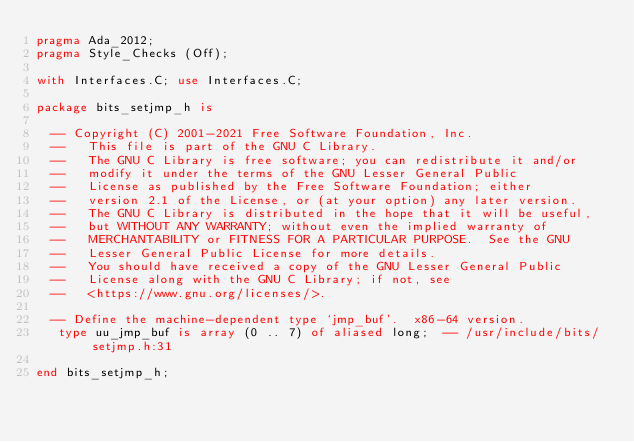<code> <loc_0><loc_0><loc_500><loc_500><_Ada_>pragma Ada_2012;
pragma Style_Checks (Off);

with Interfaces.C; use Interfaces.C;

package bits_setjmp_h is

  -- Copyright (C) 2001-2021 Free Software Foundation, Inc.
  --   This file is part of the GNU C Library.
  --   The GNU C Library is free software; you can redistribute it and/or
  --   modify it under the terms of the GNU Lesser General Public
  --   License as published by the Free Software Foundation; either
  --   version 2.1 of the License, or (at your option) any later version.
  --   The GNU C Library is distributed in the hope that it will be useful,
  --   but WITHOUT ANY WARRANTY; without even the implied warranty of
  --   MERCHANTABILITY or FITNESS FOR A PARTICULAR PURPOSE.  See the GNU
  --   Lesser General Public License for more details.
  --   You should have received a copy of the GNU Lesser General Public
  --   License along with the GNU C Library; if not, see
  --   <https://www.gnu.org/licenses/>.   

  -- Define the machine-dependent type `jmp_buf'.  x86-64 version.   
   type uu_jmp_buf is array (0 .. 7) of aliased long;  -- /usr/include/bits/setjmp.h:31

end bits_setjmp_h;
</code> 